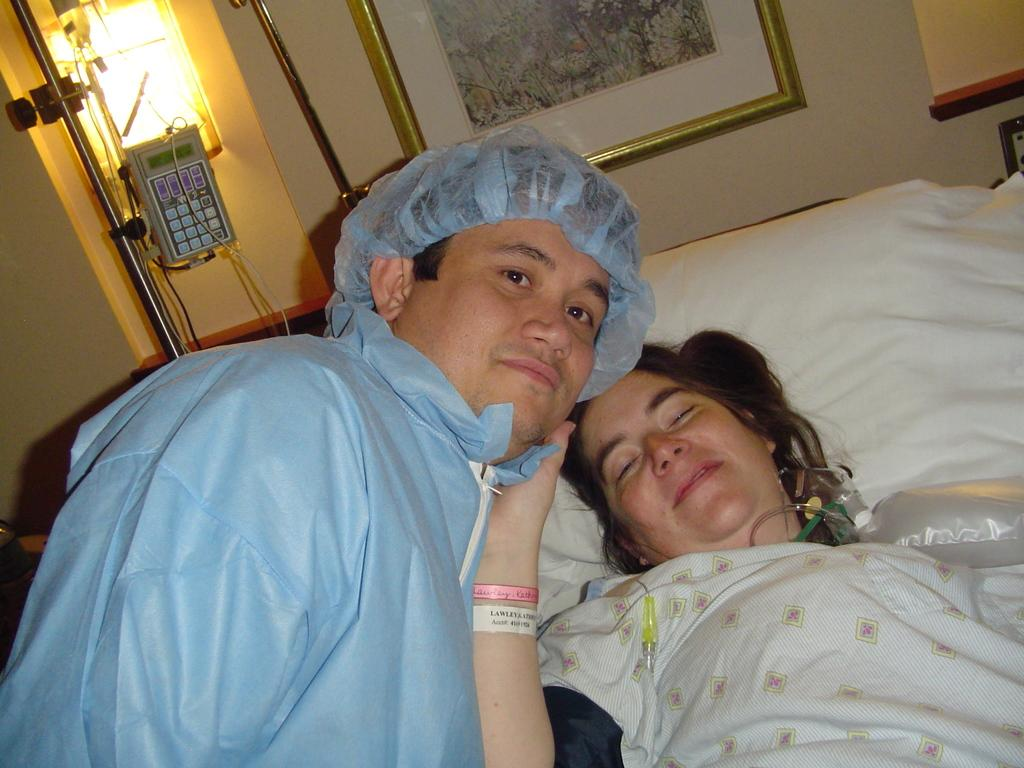How many people are in the image? There are two persons on a bed in the image. What can be seen on the wall in the background? There are photo frames on a wall in the background. What is the source of light in the background? There is a light visible in the background. What else is present in the background of the image? There are some objects in the background. Where might this image have been taken? The image is likely taken in a room. What type of throne is visible in the image? There is no throne present in the image. What channel can be seen on the television in the image? There is no television present in the image. 